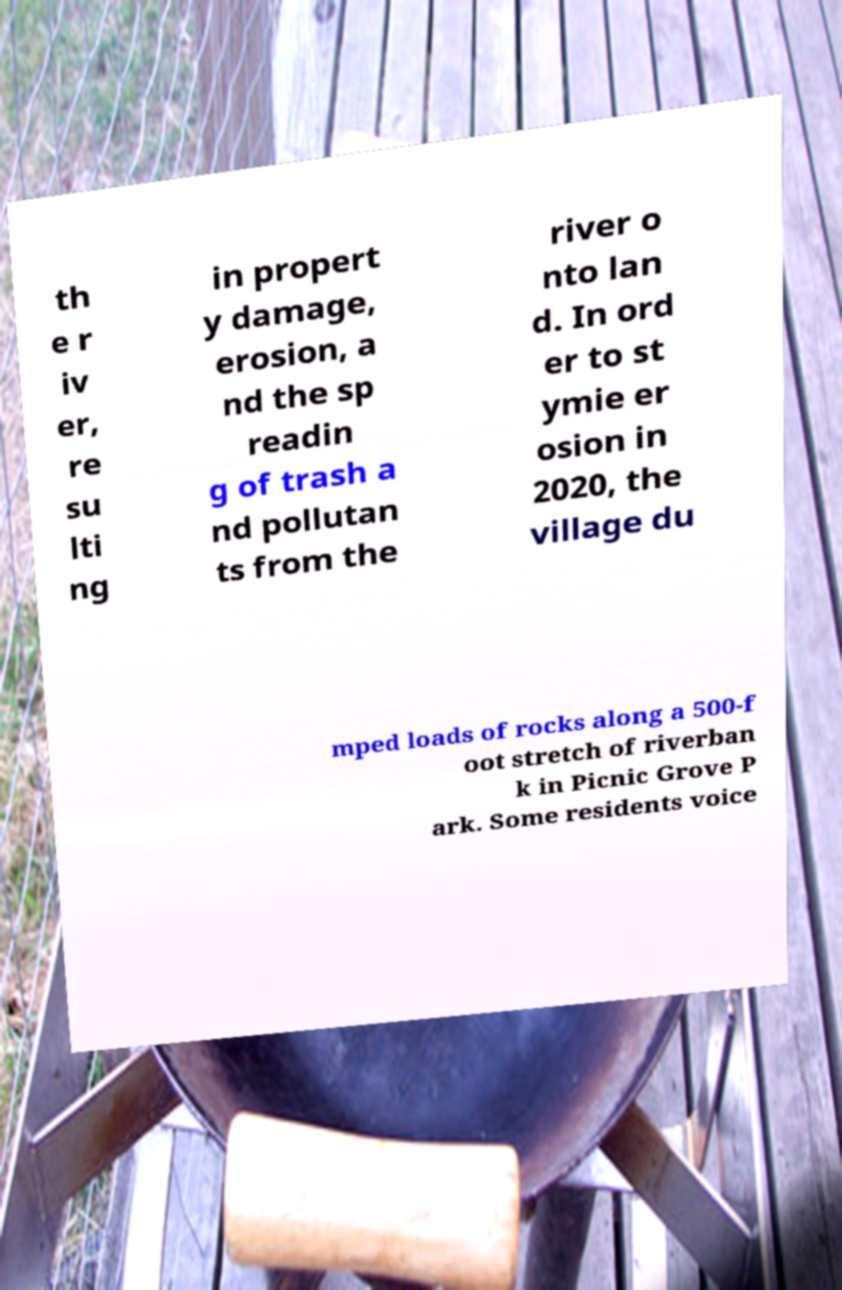What messages or text are displayed in this image? I need them in a readable, typed format. th e r iv er, re su lti ng in propert y damage, erosion, a nd the sp readin g of trash a nd pollutan ts from the river o nto lan d. In ord er to st ymie er osion in 2020, the village du mped loads of rocks along a 500-f oot stretch of riverban k in Picnic Grove P ark. Some residents voice 